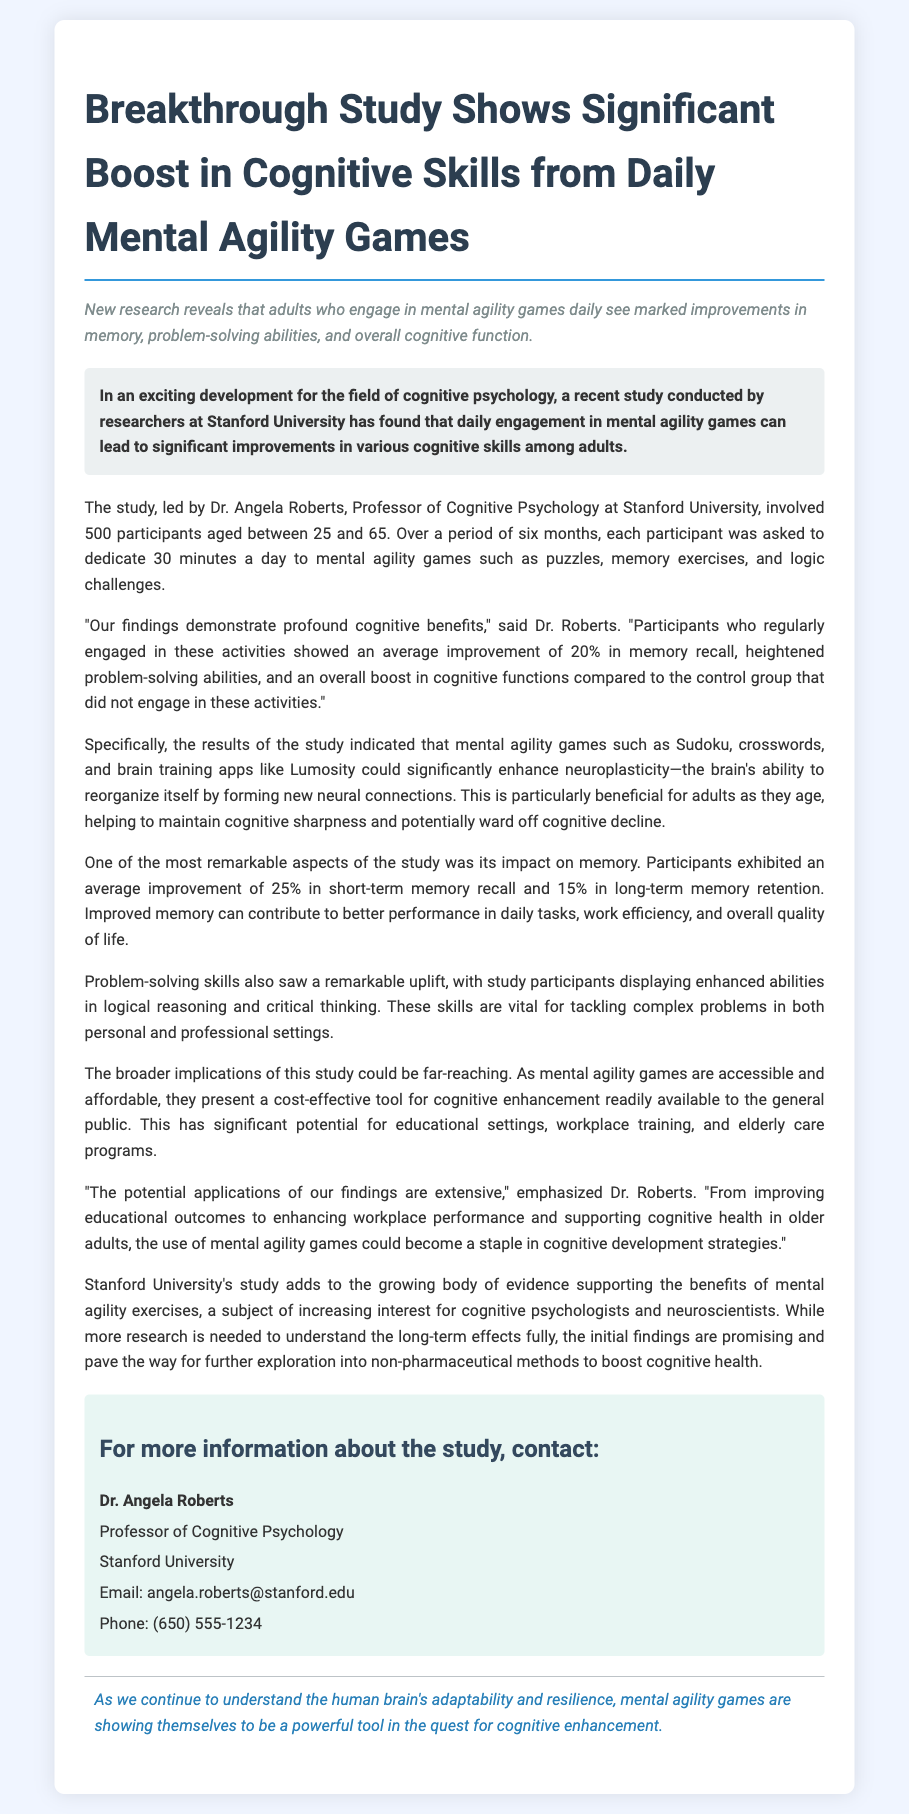What is the title of the study? The title of the study is presented at the beginning of the document, highlighting its focus on cognitive skills and mental agility games.
Answer: Breakthrough Study Shows Significant Boost in Cognitive Skills from Daily Mental Agility Games Who conducted the study? The study was carried out by researchers at a specific university mentioned in the document.
Answer: Stanford University How many participants were involved in the study? The document states the total number of participants involved in the research.
Answer: 500 What was the average improvement in memory recall among participants? The report specifies the average improvement percentage in memory recall measured during the study.
Answer: 20% What is one type of mental agility game mentioned in the study? The document lists examples of mental agility games that participants engaged in during the research.
Answer: Sudoku What role does neuroplasticity play according to the findings? The findings describe the study's focus on the brain's ability to adapt and develop through mental agility games.
Answer: Enhances neuroplasticity Who is Dr. Angela Roberts? The document provides information on the lead researcher and her professional title.
Answer: Professor of Cognitive Psychology What potential application of the findings is mentioned? The study discusses possible uses of mental agility games in various settings like education or elderly care.
Answer: Cognitive enhancement strategies What was the duration of the study? The timeline for the research is mentioned in terms of the total length of the study.
Answer: Six months 